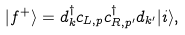<formula> <loc_0><loc_0><loc_500><loc_500>| f ^ { + } \rangle = d ^ { \dagger } _ { k } c _ { L , p } c ^ { \dagger } _ { R , p ^ { \prime } } d _ { k ^ { \prime } } | i \rangle ,</formula> 